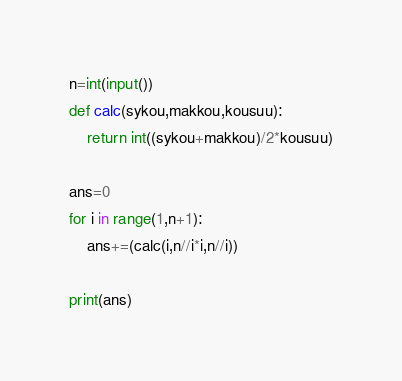<code> <loc_0><loc_0><loc_500><loc_500><_Python_>n=int(input())
def calc(sykou,makkou,kousuu):
    return int((sykou+makkou)/2*kousuu)

ans=0
for i in range(1,n+1):
    ans+=(calc(i,n//i*i,n//i))

print(ans)</code> 